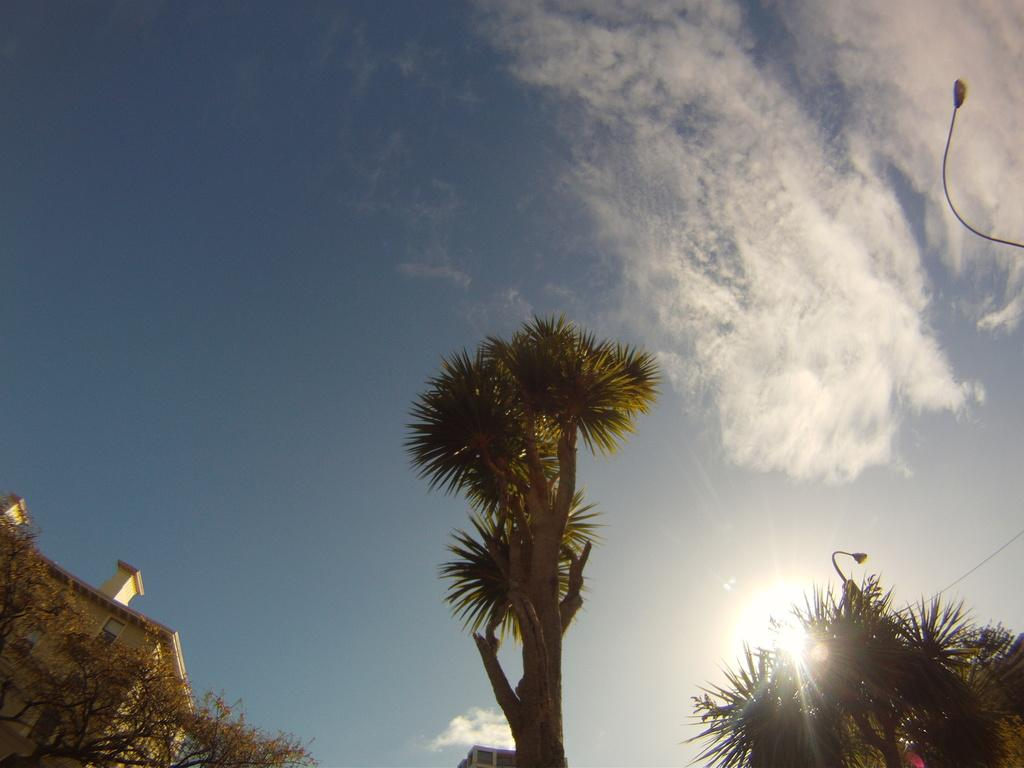What type of natural elements can be seen in the image? There are trees in the image. What type of man-made structure is present in the image? There is a building in the image. What celestial body is visible in the image? The sun is visible in the image. What is the color of the sky in the background of the image? The sky is blue in the background. What weather condition can be inferred from the image? The presence of clouds in the sky suggests that there might be some weather condition, such as partly cloudy or overcast. What type of pencil can be seen in the image? There is no pencil present in the image. What sound can be heard coming from the trees in the image? There is no sound present in the image, as it is a still image. 